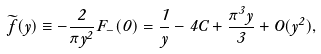<formula> <loc_0><loc_0><loc_500><loc_500>\widetilde { f } ( y ) \equiv - \frac { 2 } { \pi y ^ { 2 } } F _ { - } ( 0 ) = \frac { 1 } { y } - 4 C + \frac { \pi ^ { 3 } y } { 3 } + O ( y ^ { 2 } ) ,</formula> 